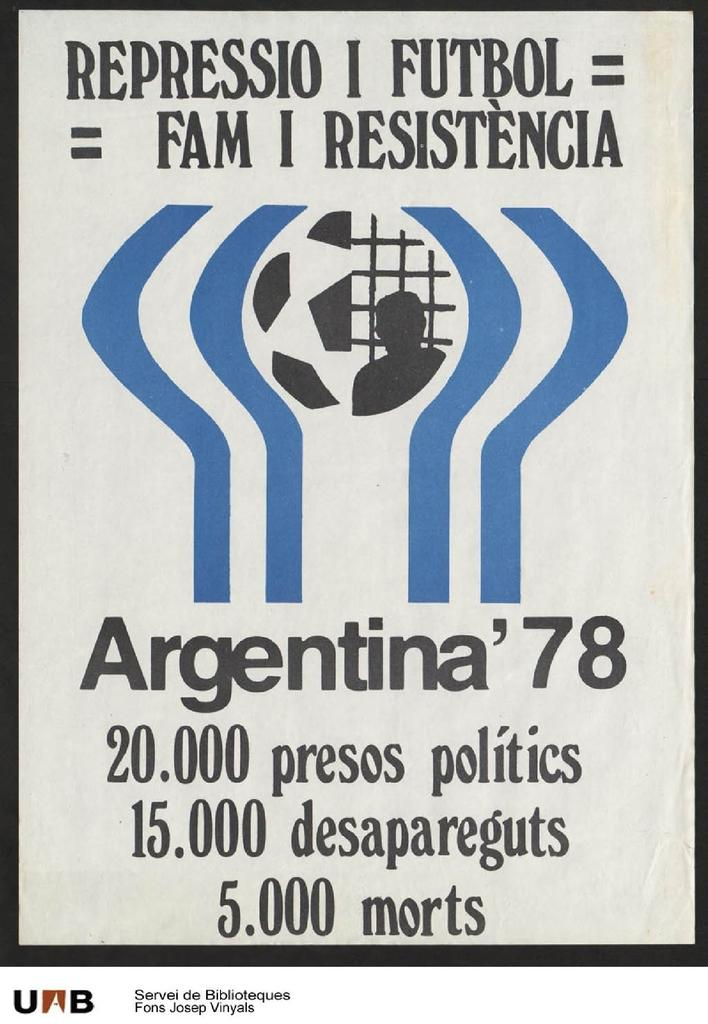<image>
Summarize the visual content of the image. A poster has information on Argentina '78 soccer. 